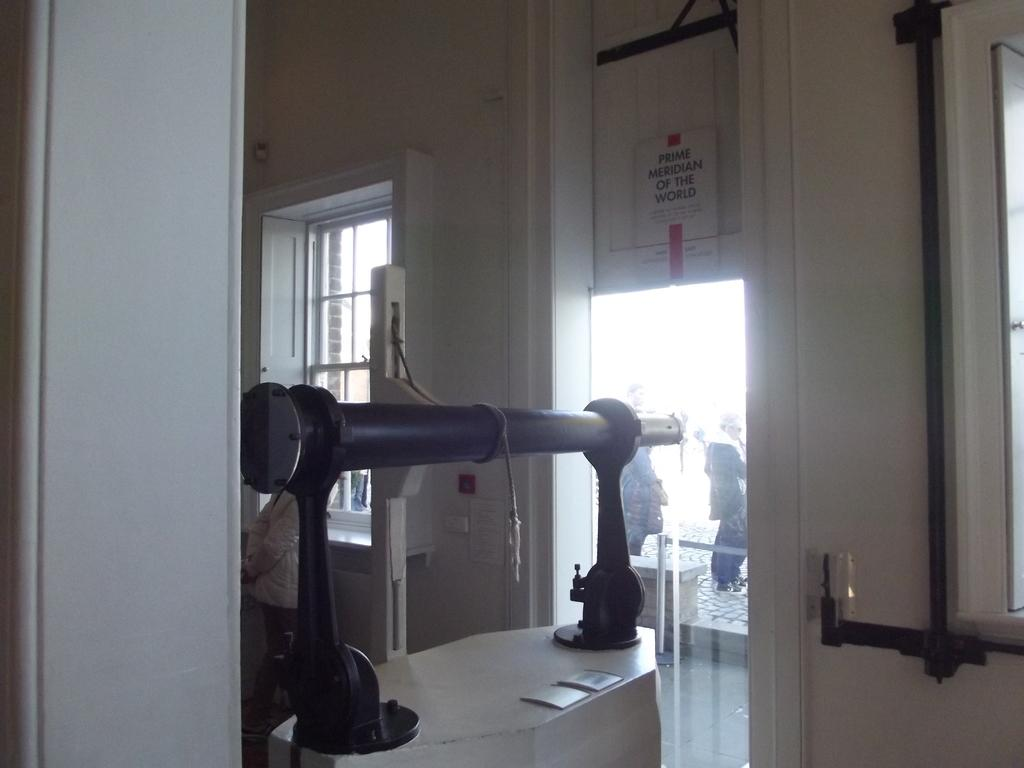What is the main subject of the image? The main subject of the image is machinery. Where is the machinery located in the image? The machinery is in the middle of the image. What type of location might the image depict? The image appears to be of a museum. What architectural feature can be seen on the left side of the image? There is a window on the left side of the image. What is the central architectural feature in the image? There is a door in the middle of the image. Can you describe the people visible outside the door? Humans are visible outside the door. How many stitches are visible on the machinery in the image? There are no stitches visible on the machinery in the image, as it is not a textile or fabric-based object. What fact can be learned about the machinery from the image? The image does not provide any specific facts about the machinery; it only shows its appearance and location. 